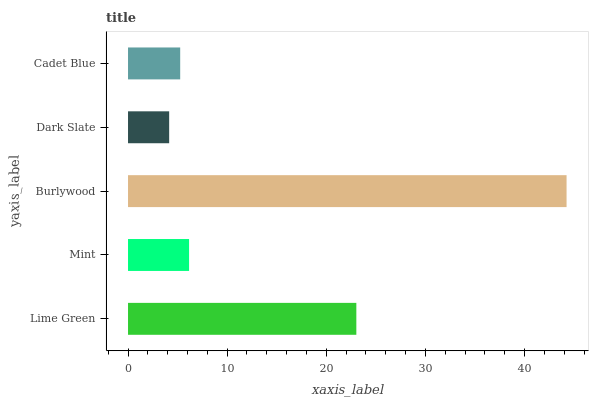Is Dark Slate the minimum?
Answer yes or no. Yes. Is Burlywood the maximum?
Answer yes or no. Yes. Is Mint the minimum?
Answer yes or no. No. Is Mint the maximum?
Answer yes or no. No. Is Lime Green greater than Mint?
Answer yes or no. Yes. Is Mint less than Lime Green?
Answer yes or no. Yes. Is Mint greater than Lime Green?
Answer yes or no. No. Is Lime Green less than Mint?
Answer yes or no. No. Is Mint the high median?
Answer yes or no. Yes. Is Mint the low median?
Answer yes or no. Yes. Is Lime Green the high median?
Answer yes or no. No. Is Dark Slate the low median?
Answer yes or no. No. 